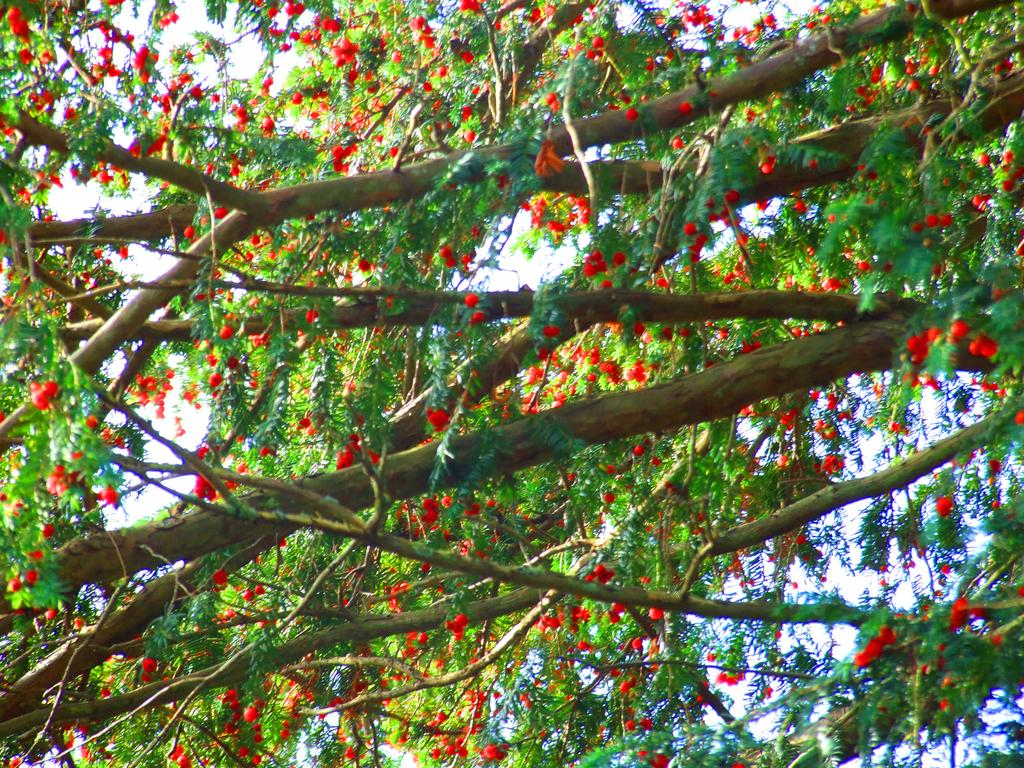What is located in the foreground of the image? There are flowers in the foreground of the image. What can be seen near the flowers? The flowers are near trees. What is visible in the background of the image? The sky is visible in the background of the image. How many bees can be seen trading their grip on the flowers in the image? There are no bees present in the image, and therefore no trading or gripping can be observed. 